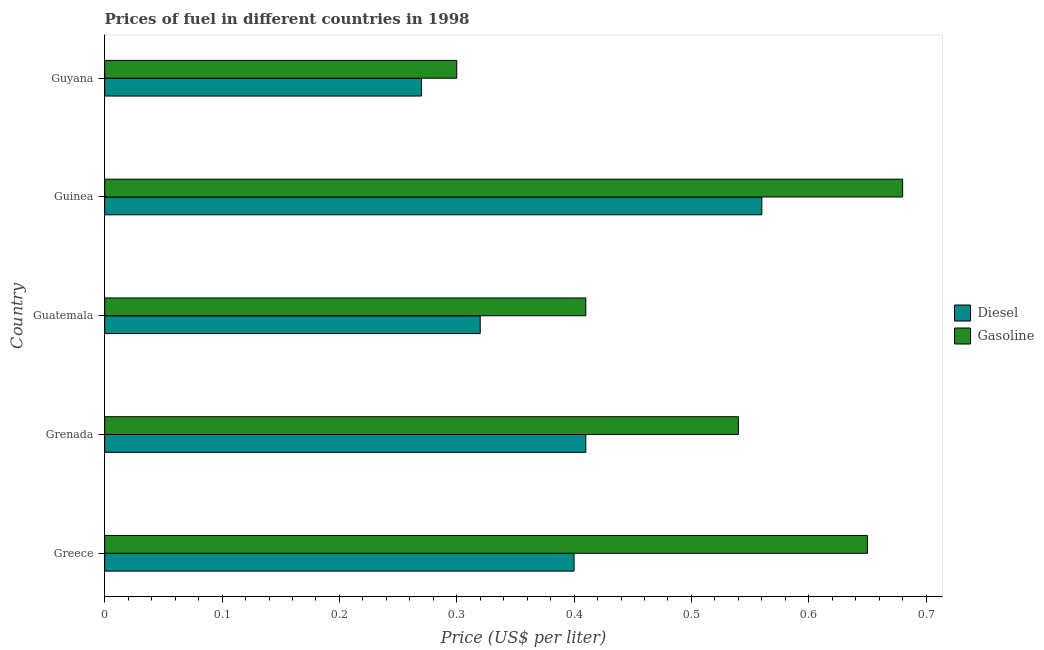How many different coloured bars are there?
Give a very brief answer. 2. Are the number of bars on each tick of the Y-axis equal?
Your answer should be compact. Yes. How many bars are there on the 3rd tick from the bottom?
Keep it short and to the point. 2. What is the label of the 3rd group of bars from the top?
Offer a terse response. Guatemala. Across all countries, what is the maximum gasoline price?
Provide a succinct answer. 0.68. Across all countries, what is the minimum diesel price?
Your answer should be compact. 0.27. In which country was the gasoline price maximum?
Your answer should be compact. Guinea. In which country was the diesel price minimum?
Your answer should be compact. Guyana. What is the total gasoline price in the graph?
Provide a short and direct response. 2.58. What is the difference between the diesel price in Greece and that in Guinea?
Keep it short and to the point. -0.16. What is the difference between the diesel price in Grenada and the gasoline price in Guyana?
Offer a very short reply. 0.11. What is the average gasoline price per country?
Give a very brief answer. 0.52. What is the difference between the gasoline price and diesel price in Grenada?
Offer a very short reply. 0.13. In how many countries, is the gasoline price greater than 0.06 US$ per litre?
Ensure brevity in your answer.  5. What is the ratio of the gasoline price in Greece to that in Grenada?
Provide a succinct answer. 1.2. Is the gasoline price in Guatemala less than that in Guyana?
Keep it short and to the point. No. Is the difference between the diesel price in Greece and Guyana greater than the difference between the gasoline price in Greece and Guyana?
Offer a very short reply. No. What is the difference between the highest and the second highest gasoline price?
Provide a succinct answer. 0.03. What is the difference between the highest and the lowest diesel price?
Offer a terse response. 0.29. In how many countries, is the gasoline price greater than the average gasoline price taken over all countries?
Your response must be concise. 3. What does the 2nd bar from the top in Guatemala represents?
Offer a very short reply. Diesel. What does the 2nd bar from the bottom in Grenada represents?
Make the answer very short. Gasoline. What is the difference between two consecutive major ticks on the X-axis?
Keep it short and to the point. 0.1. Are the values on the major ticks of X-axis written in scientific E-notation?
Make the answer very short. No. Does the graph contain any zero values?
Give a very brief answer. No. Does the graph contain grids?
Provide a succinct answer. No. What is the title of the graph?
Provide a short and direct response. Prices of fuel in different countries in 1998. Does "Time to import" appear as one of the legend labels in the graph?
Your answer should be very brief. No. What is the label or title of the X-axis?
Offer a very short reply. Price (US$ per liter). What is the Price (US$ per liter) of Gasoline in Greece?
Your answer should be compact. 0.65. What is the Price (US$ per liter) in Diesel in Grenada?
Your answer should be compact. 0.41. What is the Price (US$ per liter) in Gasoline in Grenada?
Give a very brief answer. 0.54. What is the Price (US$ per liter) of Diesel in Guatemala?
Give a very brief answer. 0.32. What is the Price (US$ per liter) of Gasoline in Guatemala?
Your response must be concise. 0.41. What is the Price (US$ per liter) in Diesel in Guinea?
Offer a very short reply. 0.56. What is the Price (US$ per liter) in Gasoline in Guinea?
Your answer should be very brief. 0.68. What is the Price (US$ per liter) in Diesel in Guyana?
Your answer should be very brief. 0.27. What is the Price (US$ per liter) of Gasoline in Guyana?
Your answer should be compact. 0.3. Across all countries, what is the maximum Price (US$ per liter) in Diesel?
Your answer should be very brief. 0.56. Across all countries, what is the maximum Price (US$ per liter) in Gasoline?
Your answer should be very brief. 0.68. Across all countries, what is the minimum Price (US$ per liter) of Diesel?
Provide a short and direct response. 0.27. What is the total Price (US$ per liter) of Diesel in the graph?
Provide a succinct answer. 1.96. What is the total Price (US$ per liter) in Gasoline in the graph?
Your answer should be very brief. 2.58. What is the difference between the Price (US$ per liter) of Diesel in Greece and that in Grenada?
Your response must be concise. -0.01. What is the difference between the Price (US$ per liter) of Gasoline in Greece and that in Grenada?
Ensure brevity in your answer.  0.11. What is the difference between the Price (US$ per liter) of Gasoline in Greece and that in Guatemala?
Provide a short and direct response. 0.24. What is the difference between the Price (US$ per liter) of Diesel in Greece and that in Guinea?
Ensure brevity in your answer.  -0.16. What is the difference between the Price (US$ per liter) of Gasoline in Greece and that in Guinea?
Make the answer very short. -0.03. What is the difference between the Price (US$ per liter) of Diesel in Greece and that in Guyana?
Your answer should be very brief. 0.13. What is the difference between the Price (US$ per liter) of Diesel in Grenada and that in Guatemala?
Provide a short and direct response. 0.09. What is the difference between the Price (US$ per liter) of Gasoline in Grenada and that in Guatemala?
Your answer should be very brief. 0.13. What is the difference between the Price (US$ per liter) of Diesel in Grenada and that in Guinea?
Make the answer very short. -0.15. What is the difference between the Price (US$ per liter) in Gasoline in Grenada and that in Guinea?
Ensure brevity in your answer.  -0.14. What is the difference between the Price (US$ per liter) in Diesel in Grenada and that in Guyana?
Give a very brief answer. 0.14. What is the difference between the Price (US$ per liter) in Gasoline in Grenada and that in Guyana?
Make the answer very short. 0.24. What is the difference between the Price (US$ per liter) in Diesel in Guatemala and that in Guinea?
Make the answer very short. -0.24. What is the difference between the Price (US$ per liter) of Gasoline in Guatemala and that in Guinea?
Offer a very short reply. -0.27. What is the difference between the Price (US$ per liter) of Diesel in Guatemala and that in Guyana?
Your answer should be compact. 0.05. What is the difference between the Price (US$ per liter) in Gasoline in Guatemala and that in Guyana?
Ensure brevity in your answer.  0.11. What is the difference between the Price (US$ per liter) in Diesel in Guinea and that in Guyana?
Your answer should be very brief. 0.29. What is the difference between the Price (US$ per liter) of Gasoline in Guinea and that in Guyana?
Make the answer very short. 0.38. What is the difference between the Price (US$ per liter) of Diesel in Greece and the Price (US$ per liter) of Gasoline in Grenada?
Provide a succinct answer. -0.14. What is the difference between the Price (US$ per liter) of Diesel in Greece and the Price (US$ per liter) of Gasoline in Guatemala?
Your answer should be very brief. -0.01. What is the difference between the Price (US$ per liter) in Diesel in Greece and the Price (US$ per liter) in Gasoline in Guinea?
Make the answer very short. -0.28. What is the difference between the Price (US$ per liter) in Diesel in Greece and the Price (US$ per liter) in Gasoline in Guyana?
Provide a succinct answer. 0.1. What is the difference between the Price (US$ per liter) in Diesel in Grenada and the Price (US$ per liter) in Gasoline in Guinea?
Ensure brevity in your answer.  -0.27. What is the difference between the Price (US$ per liter) in Diesel in Grenada and the Price (US$ per liter) in Gasoline in Guyana?
Keep it short and to the point. 0.11. What is the difference between the Price (US$ per liter) of Diesel in Guatemala and the Price (US$ per liter) of Gasoline in Guinea?
Your response must be concise. -0.36. What is the difference between the Price (US$ per liter) in Diesel in Guatemala and the Price (US$ per liter) in Gasoline in Guyana?
Give a very brief answer. 0.02. What is the difference between the Price (US$ per liter) in Diesel in Guinea and the Price (US$ per liter) in Gasoline in Guyana?
Offer a very short reply. 0.26. What is the average Price (US$ per liter) of Diesel per country?
Ensure brevity in your answer.  0.39. What is the average Price (US$ per liter) in Gasoline per country?
Give a very brief answer. 0.52. What is the difference between the Price (US$ per liter) of Diesel and Price (US$ per liter) of Gasoline in Greece?
Offer a terse response. -0.25. What is the difference between the Price (US$ per liter) in Diesel and Price (US$ per liter) in Gasoline in Grenada?
Ensure brevity in your answer.  -0.13. What is the difference between the Price (US$ per liter) in Diesel and Price (US$ per liter) in Gasoline in Guatemala?
Offer a terse response. -0.09. What is the difference between the Price (US$ per liter) of Diesel and Price (US$ per liter) of Gasoline in Guinea?
Give a very brief answer. -0.12. What is the difference between the Price (US$ per liter) in Diesel and Price (US$ per liter) in Gasoline in Guyana?
Provide a succinct answer. -0.03. What is the ratio of the Price (US$ per liter) in Diesel in Greece to that in Grenada?
Provide a short and direct response. 0.98. What is the ratio of the Price (US$ per liter) in Gasoline in Greece to that in Grenada?
Provide a succinct answer. 1.2. What is the ratio of the Price (US$ per liter) of Diesel in Greece to that in Guatemala?
Your response must be concise. 1.25. What is the ratio of the Price (US$ per liter) in Gasoline in Greece to that in Guatemala?
Ensure brevity in your answer.  1.59. What is the ratio of the Price (US$ per liter) of Diesel in Greece to that in Guinea?
Make the answer very short. 0.71. What is the ratio of the Price (US$ per liter) in Gasoline in Greece to that in Guinea?
Keep it short and to the point. 0.96. What is the ratio of the Price (US$ per liter) in Diesel in Greece to that in Guyana?
Your answer should be compact. 1.48. What is the ratio of the Price (US$ per liter) in Gasoline in Greece to that in Guyana?
Your answer should be very brief. 2.17. What is the ratio of the Price (US$ per liter) of Diesel in Grenada to that in Guatemala?
Provide a succinct answer. 1.28. What is the ratio of the Price (US$ per liter) in Gasoline in Grenada to that in Guatemala?
Make the answer very short. 1.32. What is the ratio of the Price (US$ per liter) of Diesel in Grenada to that in Guinea?
Offer a terse response. 0.73. What is the ratio of the Price (US$ per liter) in Gasoline in Grenada to that in Guinea?
Your answer should be very brief. 0.79. What is the ratio of the Price (US$ per liter) of Diesel in Grenada to that in Guyana?
Your response must be concise. 1.52. What is the ratio of the Price (US$ per liter) in Diesel in Guatemala to that in Guinea?
Make the answer very short. 0.57. What is the ratio of the Price (US$ per liter) of Gasoline in Guatemala to that in Guinea?
Your response must be concise. 0.6. What is the ratio of the Price (US$ per liter) of Diesel in Guatemala to that in Guyana?
Offer a very short reply. 1.19. What is the ratio of the Price (US$ per liter) of Gasoline in Guatemala to that in Guyana?
Your answer should be compact. 1.37. What is the ratio of the Price (US$ per liter) in Diesel in Guinea to that in Guyana?
Give a very brief answer. 2.07. What is the ratio of the Price (US$ per liter) in Gasoline in Guinea to that in Guyana?
Offer a terse response. 2.27. What is the difference between the highest and the second highest Price (US$ per liter) of Gasoline?
Make the answer very short. 0.03. What is the difference between the highest and the lowest Price (US$ per liter) of Diesel?
Provide a short and direct response. 0.29. What is the difference between the highest and the lowest Price (US$ per liter) in Gasoline?
Ensure brevity in your answer.  0.38. 